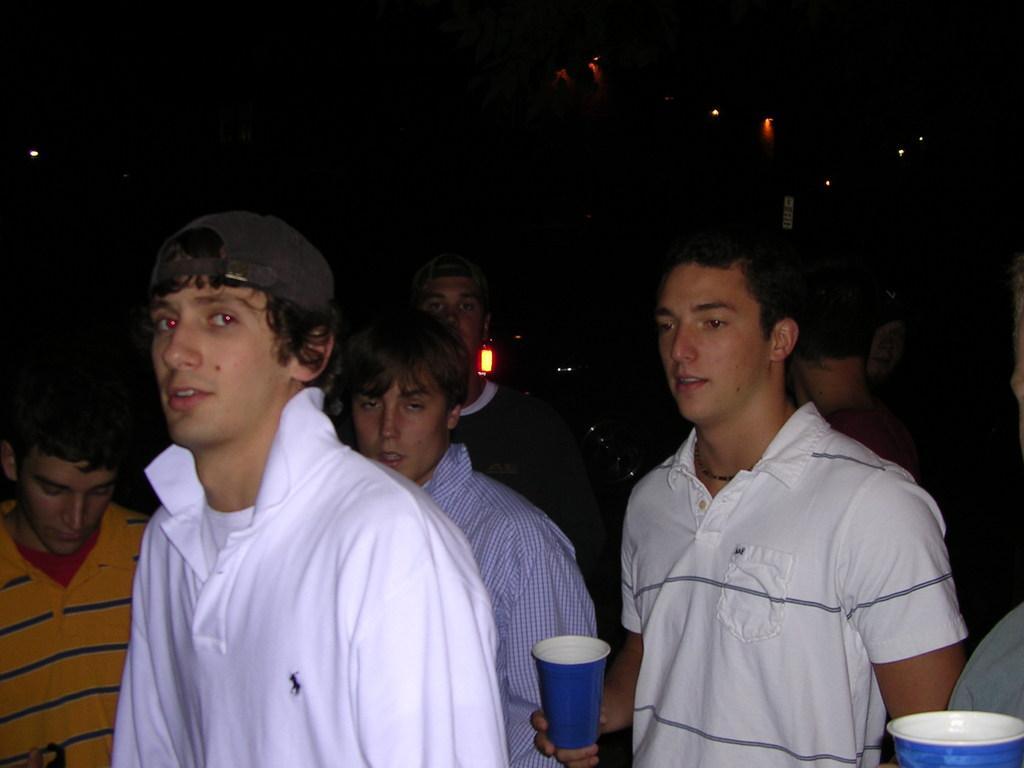How would you summarize this image in a sentence or two? In this picture there are people in the center of the image, few of them are holding glasses in their hands and there are lights in the background area of the image. 